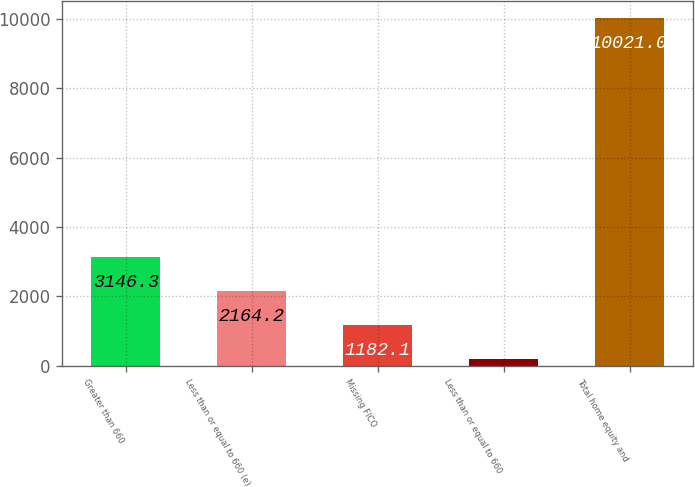Convert chart. <chart><loc_0><loc_0><loc_500><loc_500><bar_chart><fcel>Greater than 660<fcel>Less than or equal to 660 (e)<fcel>Missing FICO<fcel>Less than or equal to 660<fcel>Total home equity and<nl><fcel>3146.3<fcel>2164.2<fcel>1182.1<fcel>200<fcel>10021<nl></chart> 